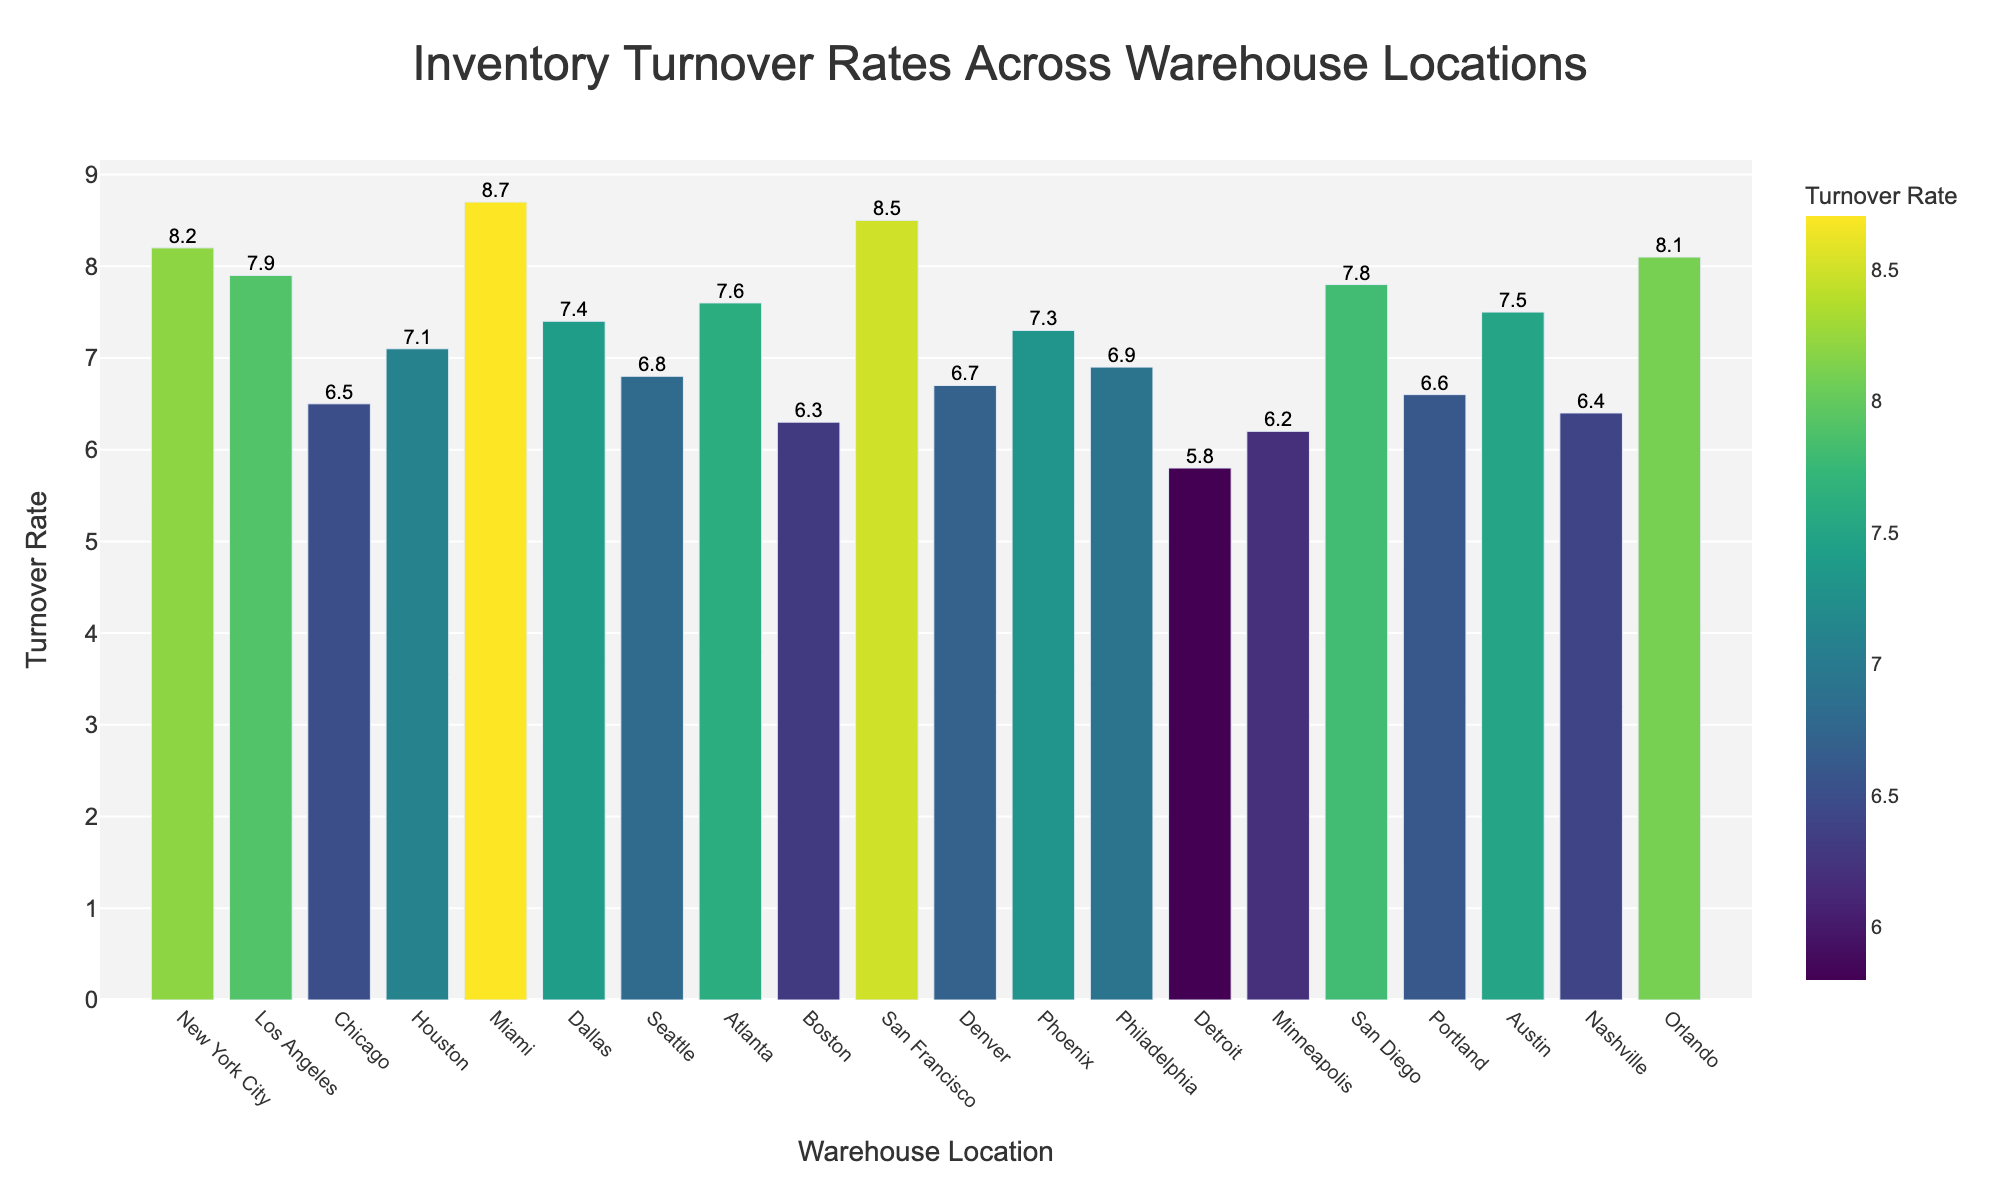Which warehouse location has the highest inventory turnover rate? The highest inventory turnover rate can be determined by looking at the tallest bar. The tallest bar represents Miami with an inventory turnover rate of 8.7.
Answer: Miami Which warehouse location has the lowest inventory turnover rate? The lowest inventory turnover rate can be identified by finding the shortest bar. The shortest bar represents Detroit with an inventory turnover rate of 5.8.
Answer: Detroit What is the average inventory turnover rate of all warehouse locations? To calculate the average inventory turnover rate, sum all the rates and divide by the number of locations. Summing the rates gives (8.2 + 7.9 + 6.5 + 7.1 + 8.7 + 7.4 + 6.8 + 7.6 + 6.3 + 8.5 + 6.7 + 7.3 + 6.9 + 5.8 + 6.2 + 7.8 + 6.6 + 7.5 + 6.4 + 8.1) = 142.3. There are 20 locations, so the average is 142.3 / 20 = 7.1.
Answer: 7.1 How many warehouse locations have an inventory turnover rate above 7.0? Count the number of warehouse locations with bars taller than the 7.0 mark. These locations are New York City, Los Angeles, Houston, Miami, Dallas, Atlanta, San Francisco, Phoenix, San Diego, Austin, and Orlando, totaling 11 locations.
Answer: 11 What is the combined inventory turnover rate of Boston and Detroit? Sum the inventory turnover rates of Boston and Detroit. Boston has 6.3 and Detroit has 5.8, so the combined rate is 6.3 + 5.8 = 12.1.
Answer: 12.1 Which warehouse location has a higher inventory turnover rate: Seattle or Portland? Compare the bars of Seattle and Portland. Seattle has a turnover rate of 6.8, while Portland has a turnover rate of 6.6. Seattle's bar is taller, indicating a higher rate.
Answer: Seattle What is the difference between the highest and lowest inventory turnover rates? Subtract the lowest inventory turnover rate (Detroit, 5.8) from the highest inventory turnover rate (Miami, 8.7). The difference is 8.7 - 5.8 = 2.9.
Answer: 2.9 If the inventory turnover rate for Houston increases by 1.3, what will be the new rate? Add 1.3 to the current Houston rate of 7.1. The new rate is 7.1 + 1.3 = 8.4.
Answer: 8.4 Which warehouse locations have inventory turnover rates closest to 7.5? Identify the bars closest to the 7.5 mark. Austin has a rate of 7.5. Dallas has a rate of 7.4 and Atlanta has a rate of 7.6. All are close, but Austin is exact.
Answer: Austin, Dallas, Atlanta 